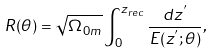<formula> <loc_0><loc_0><loc_500><loc_500>R ( \theta ) = \sqrt { \Omega _ { 0 m } } \int _ { 0 } ^ { z _ { r e c } } \frac { d z ^ { ^ { \prime } } } { E ( z ^ { ^ { \prime } } ; \theta ) } ,</formula> 